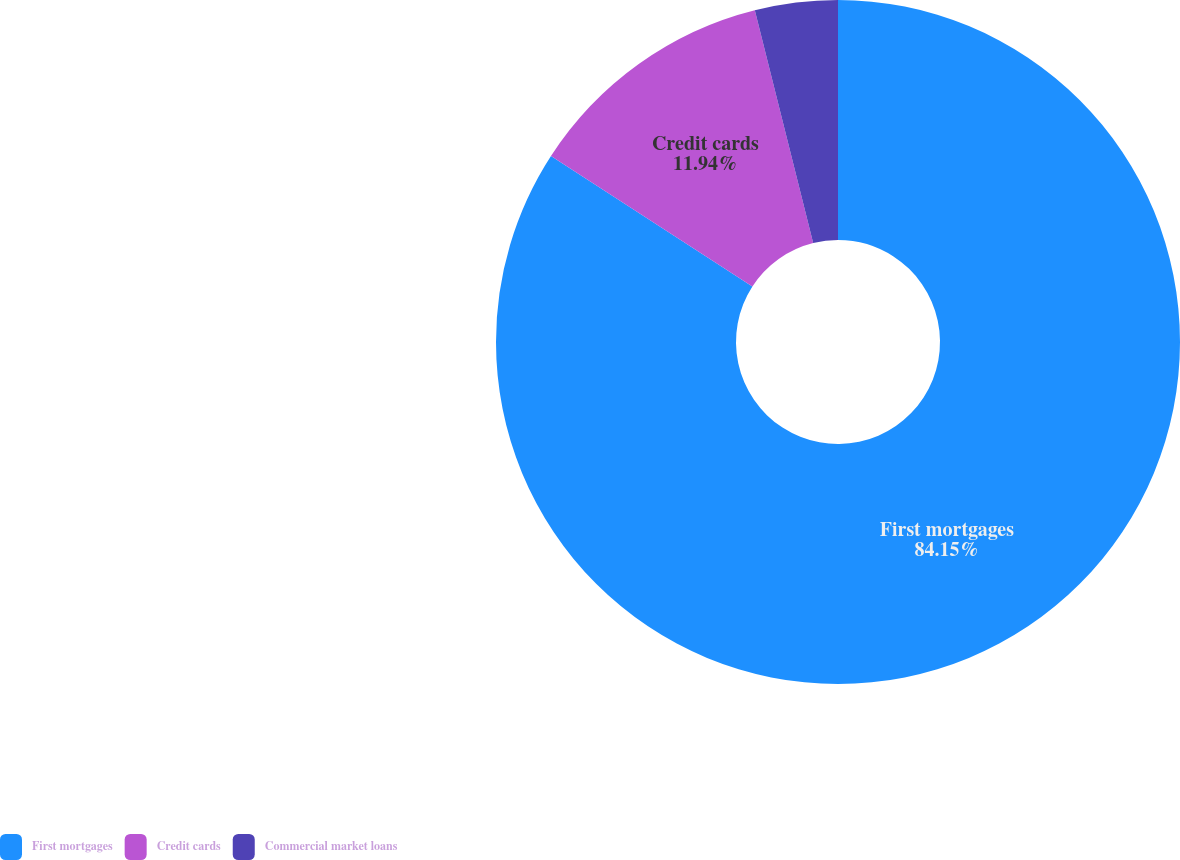Convert chart to OTSL. <chart><loc_0><loc_0><loc_500><loc_500><pie_chart><fcel>First mortgages<fcel>Credit cards<fcel>Commercial market loans<nl><fcel>84.15%<fcel>11.94%<fcel>3.91%<nl></chart> 